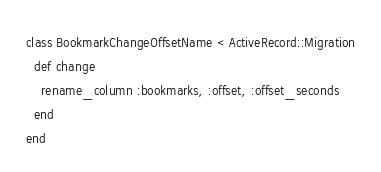<code> <loc_0><loc_0><loc_500><loc_500><_Ruby_>class BookmarkChangeOffsetName < ActiveRecord::Migration
  def change
    rename_column :bookmarks, :offset, :offset_seconds
  end
end
</code> 